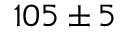Convert formula to latex. <formula><loc_0><loc_0><loc_500><loc_500>{ 1 0 5 \pm 5 }</formula> 